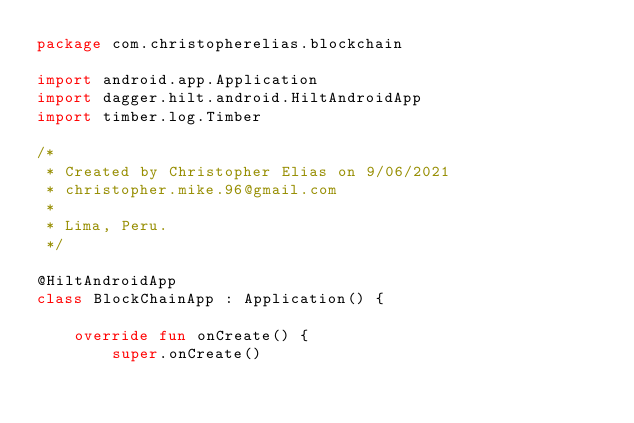Convert code to text. <code><loc_0><loc_0><loc_500><loc_500><_Kotlin_>package com.christopherelias.blockchain

import android.app.Application
import dagger.hilt.android.HiltAndroidApp
import timber.log.Timber

/*
 * Created by Christopher Elias on 9/06/2021
 * christopher.mike.96@gmail.com
 *
 * Lima, Peru.
 */

@HiltAndroidApp
class BlockChainApp : Application() {

    override fun onCreate() {
        super.onCreate()</code> 